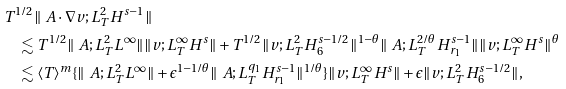Convert formula to latex. <formula><loc_0><loc_0><loc_500><loc_500>& T ^ { 1 / 2 } \| \ A \cdot \nabla v ; L _ { T } ^ { 2 } H ^ { s - 1 } \| \\ & \quad \lesssim T ^ { 1 / 2 } \| \ A ; L ^ { 2 } _ { T } L ^ { \infty } \| \| v ; L _ { T } ^ { \infty } H ^ { s } \| + T ^ { 1 / 2 } \| v ; L _ { T } ^ { 2 } H ^ { s - 1 / 2 } _ { 6 } \| ^ { 1 - \theta } \| \ A ; L ^ { 2 / \theta } _ { T } H ^ { s - 1 } _ { r _ { 1 } } \| \| v ; L _ { T } ^ { \infty } H ^ { s } \| ^ { \theta } \\ & \quad \lesssim \langle T \rangle ^ { m } \{ \| \ A ; L ^ { 2 } _ { T } L ^ { \infty } \| + \epsilon ^ { 1 - 1 / \theta } \| \ A ; L _ { T } ^ { q _ { 1 } } H ^ { s - 1 } _ { r _ { 1 } } \| ^ { 1 / \theta } \} \| v ; L _ { T } ^ { \infty } H ^ { s } \| + \epsilon \| v ; L _ { T } ^ { 2 } H ^ { s - 1 / 2 } _ { 6 } \| ,</formula> 